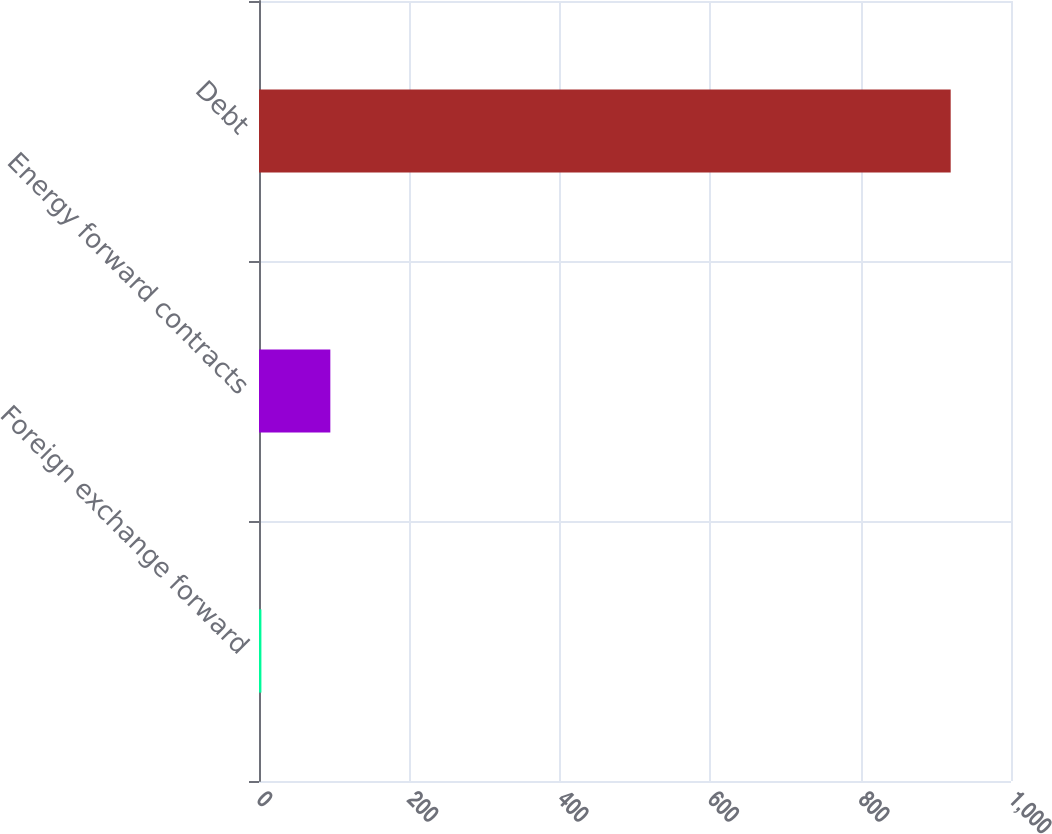Convert chart. <chart><loc_0><loc_0><loc_500><loc_500><bar_chart><fcel>Foreign exchange forward<fcel>Energy forward contracts<fcel>Debt<nl><fcel>3.2<fcel>94.86<fcel>919.8<nl></chart> 